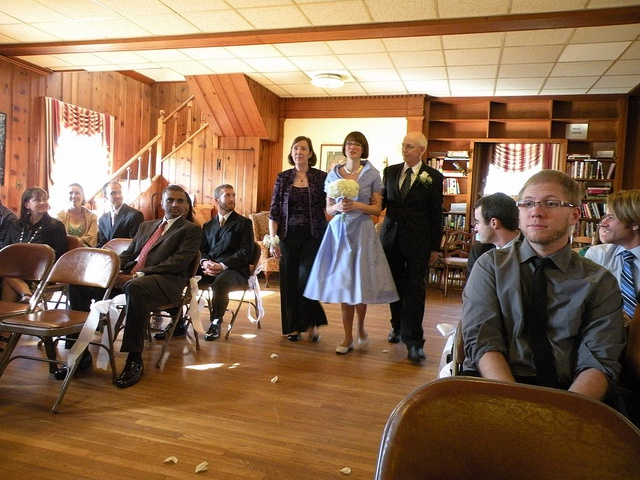Describe the objects in this image and their specific colors. I can see people in tan, black, gray, and maroon tones, chair in tan, maroon, black, and gray tones, people in tan, black, gray, and maroon tones, people in beige, gray, darkgray, and maroon tones, and people in tan, black, gray, and maroon tones in this image. 